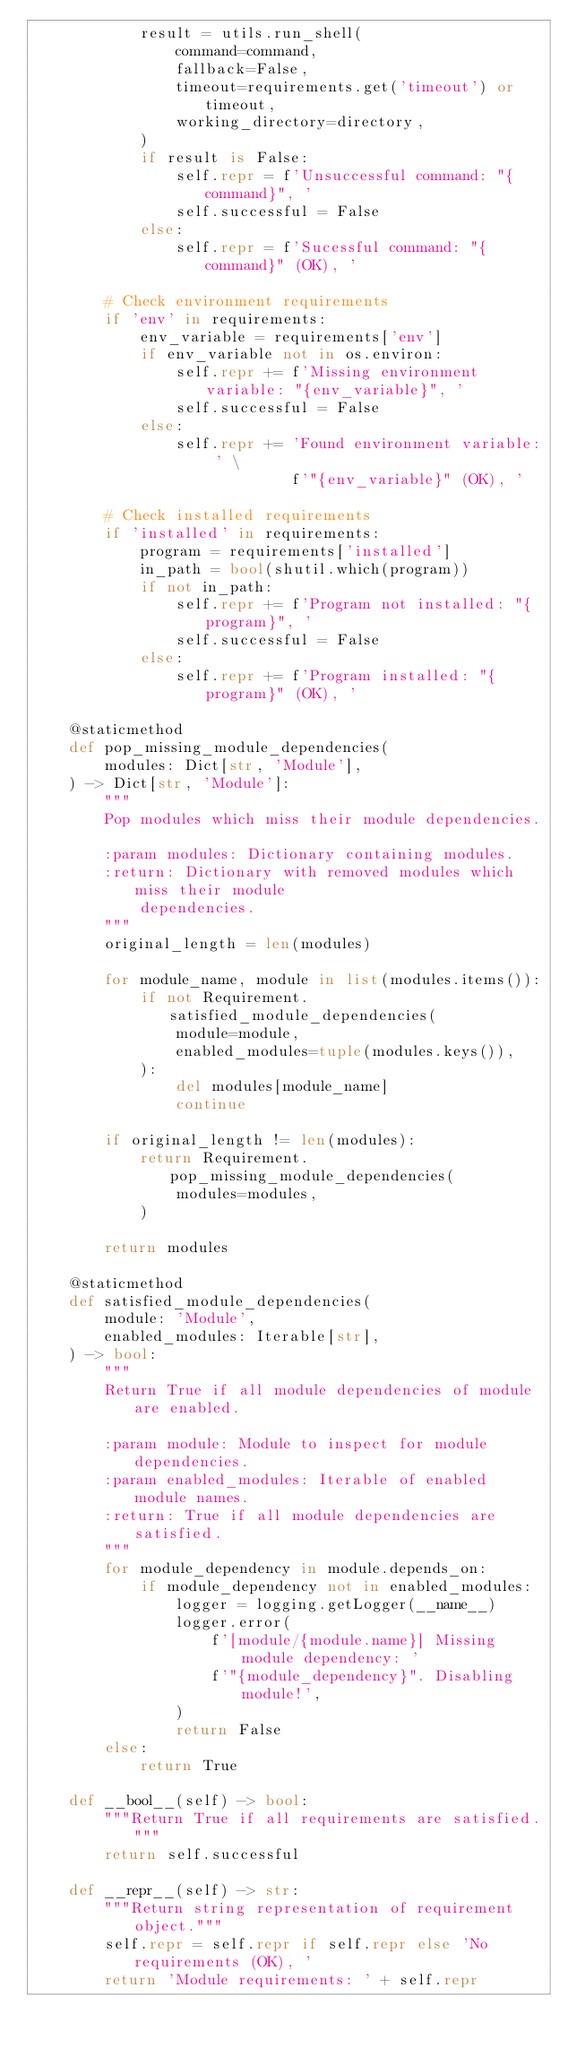<code> <loc_0><loc_0><loc_500><loc_500><_Python_>            result = utils.run_shell(
                command=command,
                fallback=False,
                timeout=requirements.get('timeout') or timeout,
                working_directory=directory,
            )
            if result is False:
                self.repr = f'Unsuccessful command: "{command}", '
                self.successful = False
            else:
                self.repr = f'Sucessful command: "{command}" (OK), '

        # Check environment requirements
        if 'env' in requirements:
            env_variable = requirements['env']
            if env_variable not in os.environ:
                self.repr += f'Missing environment variable: "{env_variable}", '
                self.successful = False
            else:
                self.repr += 'Found environment variable: ' \
                             f'"{env_variable}" (OK), '

        # Check installed requirements
        if 'installed' in requirements:
            program = requirements['installed']
            in_path = bool(shutil.which(program))
            if not in_path:
                self.repr += f'Program not installed: "{program}", '
                self.successful = False
            else:
                self.repr += f'Program installed: "{program}" (OK), '

    @staticmethod
    def pop_missing_module_dependencies(
        modules: Dict[str, 'Module'],
    ) -> Dict[str, 'Module']:
        """
        Pop modules which miss their module dependencies.

        :param modules: Dictionary containing modules.
        :return: Dictionary with removed modules which miss their module
            dependencies.
        """
        original_length = len(modules)

        for module_name, module in list(modules.items()):
            if not Requirement.satisfied_module_dependencies(
                module=module,
                enabled_modules=tuple(modules.keys()),
            ):
                del modules[module_name]
                continue

        if original_length != len(modules):
            return Requirement.pop_missing_module_dependencies(
                modules=modules,
            )

        return modules

    @staticmethod
    def satisfied_module_dependencies(
        module: 'Module',
        enabled_modules: Iterable[str],
    ) -> bool:
        """
        Return True if all module dependencies of module are enabled.

        :param module: Module to inspect for module dependencies.
        :param enabled_modules: Iterable of enabled module names.
        :return: True if all module dependencies are satisfied.
        """
        for module_dependency in module.depends_on:
            if module_dependency not in enabled_modules:
                logger = logging.getLogger(__name__)
                logger.error(
                    f'[module/{module.name}] Missing module dependency: '
                    f'"{module_dependency}". Disabling module!',
                )
                return False
        else:
            return True

    def __bool__(self) -> bool:
        """Return True if all requirements are satisfied."""
        return self.successful

    def __repr__(self) -> str:
        """Return string representation of requirement object."""
        self.repr = self.repr if self.repr else 'No requirements (OK), '
        return 'Module requirements: ' + self.repr
</code> 